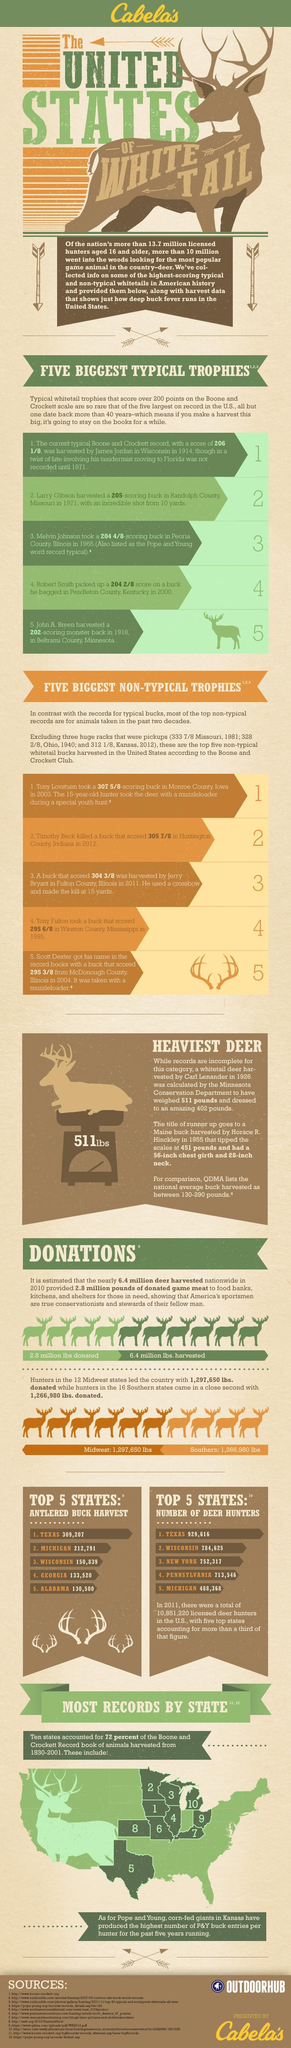How many Deer hunters are present in the state of Michigan?
Answer the question with a short phrase. 488,368 How many Deer hunters are present in the state of Texas? 929,616 Which is the state with second lowest number of Deer Hunters? Pennsylvania Which state Of U.S has second highest number in Antlered Buck Harvest? Michigan What is the number of Antlered Buck harvest in Wisconsin? 150,839 